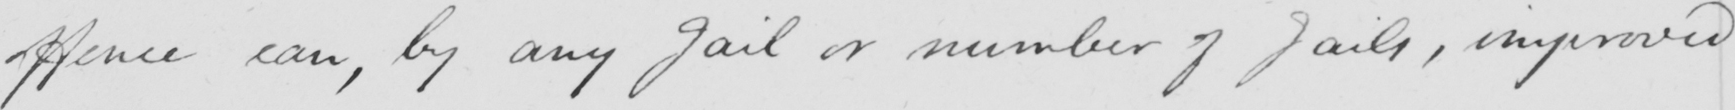Can you read and transcribe this handwriting? offence can, by any Jail or number of Jails, improved 